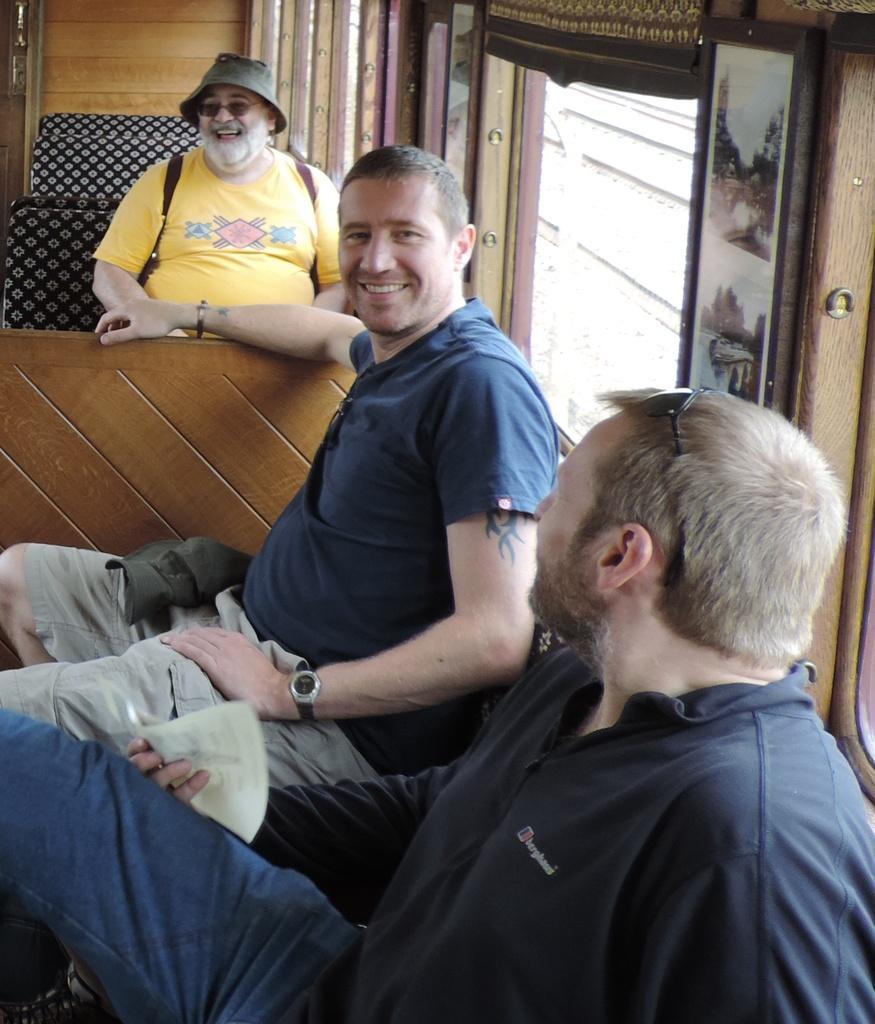How would you summarize this image in a sentence or two? In this image I can see three people with different color dresses. I can see these people are wearing the goggles and one person with the hat. These people are siting in the vehicle. To the side I can see the window. 